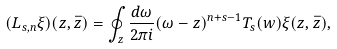<formula> <loc_0><loc_0><loc_500><loc_500>( L _ { s , n } \xi ) ( z , \bar { z } ) = \oint _ { z } \frac { d \omega } { 2 \pi i } ( \omega - z ) ^ { n + s - 1 } T _ { s } ( w ) \xi ( z , \bar { z } ) ,</formula> 